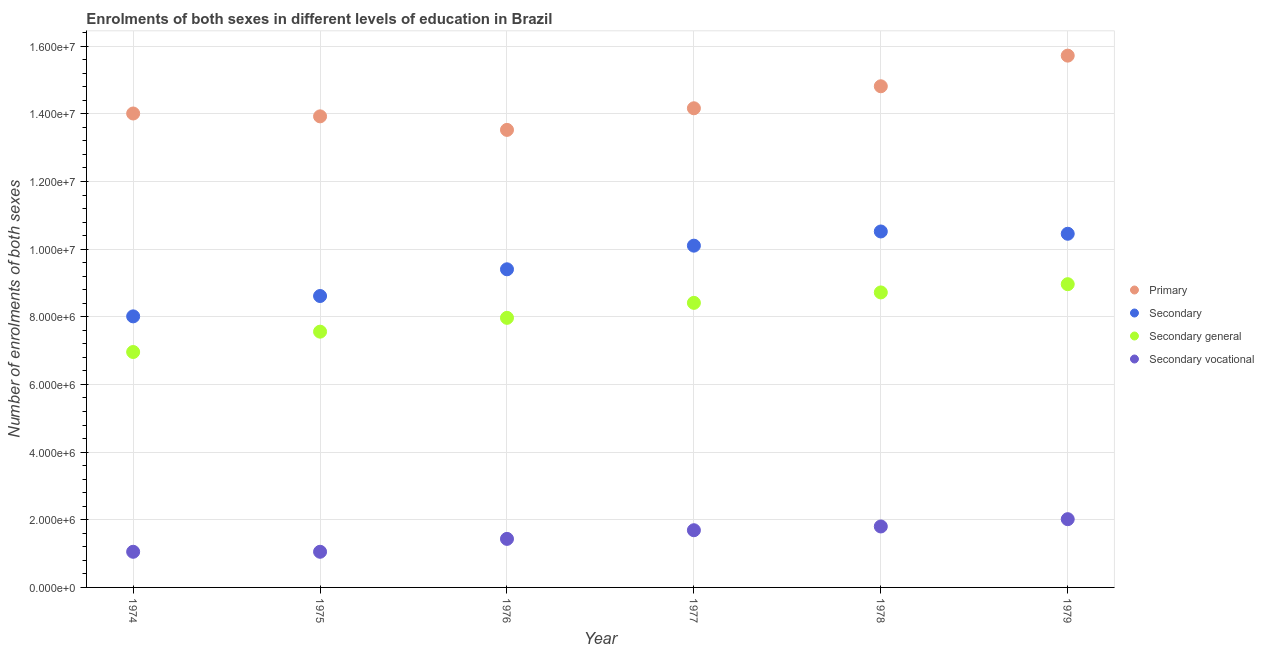How many different coloured dotlines are there?
Your answer should be very brief. 4. Is the number of dotlines equal to the number of legend labels?
Your response must be concise. Yes. What is the number of enrolments in secondary vocational education in 1975?
Make the answer very short. 1.05e+06. Across all years, what is the maximum number of enrolments in primary education?
Your answer should be very brief. 1.57e+07. Across all years, what is the minimum number of enrolments in secondary vocational education?
Your answer should be compact. 1.05e+06. In which year was the number of enrolments in secondary education maximum?
Offer a very short reply. 1978. In which year was the number of enrolments in primary education minimum?
Provide a succinct answer. 1976. What is the total number of enrolments in secondary general education in the graph?
Make the answer very short. 4.86e+07. What is the difference between the number of enrolments in primary education in 1974 and that in 1976?
Your answer should be very brief. 4.85e+05. What is the difference between the number of enrolments in secondary education in 1979 and the number of enrolments in primary education in 1978?
Your answer should be very brief. -4.36e+06. What is the average number of enrolments in primary education per year?
Provide a short and direct response. 1.44e+07. In the year 1975, what is the difference between the number of enrolments in secondary vocational education and number of enrolments in secondary general education?
Your answer should be very brief. -6.51e+06. What is the ratio of the number of enrolments in secondary vocational education in 1977 to that in 1979?
Ensure brevity in your answer.  0.84. Is the number of enrolments in secondary general education in 1976 less than that in 1977?
Offer a terse response. Yes. Is the difference between the number of enrolments in secondary vocational education in 1976 and 1979 greater than the difference between the number of enrolments in secondary general education in 1976 and 1979?
Your response must be concise. Yes. What is the difference between the highest and the second highest number of enrolments in primary education?
Keep it short and to the point. 9.06e+05. What is the difference between the highest and the lowest number of enrolments in primary education?
Provide a short and direct response. 2.20e+06. In how many years, is the number of enrolments in secondary education greater than the average number of enrolments in secondary education taken over all years?
Your answer should be very brief. 3. Is the sum of the number of enrolments in primary education in 1978 and 1979 greater than the maximum number of enrolments in secondary education across all years?
Your answer should be very brief. Yes. Is it the case that in every year, the sum of the number of enrolments in secondary general education and number of enrolments in primary education is greater than the sum of number of enrolments in secondary vocational education and number of enrolments in secondary education?
Your answer should be very brief. Yes. Is it the case that in every year, the sum of the number of enrolments in primary education and number of enrolments in secondary education is greater than the number of enrolments in secondary general education?
Your answer should be compact. Yes. How many years are there in the graph?
Make the answer very short. 6. Does the graph contain any zero values?
Keep it short and to the point. No. Where does the legend appear in the graph?
Your response must be concise. Center right. What is the title of the graph?
Provide a short and direct response. Enrolments of both sexes in different levels of education in Brazil. What is the label or title of the Y-axis?
Give a very brief answer. Number of enrolments of both sexes. What is the Number of enrolments of both sexes of Primary in 1974?
Offer a very short reply. 1.40e+07. What is the Number of enrolments of both sexes in Secondary in 1974?
Ensure brevity in your answer.  8.01e+06. What is the Number of enrolments of both sexes of Secondary general in 1974?
Your answer should be compact. 6.96e+06. What is the Number of enrolments of both sexes in Secondary vocational in 1974?
Your answer should be compact. 1.05e+06. What is the Number of enrolments of both sexes of Primary in 1975?
Ensure brevity in your answer.  1.39e+07. What is the Number of enrolments of both sexes in Secondary in 1975?
Your answer should be compact. 8.61e+06. What is the Number of enrolments of both sexes in Secondary general in 1975?
Offer a terse response. 7.56e+06. What is the Number of enrolments of both sexes in Secondary vocational in 1975?
Make the answer very short. 1.05e+06. What is the Number of enrolments of both sexes of Primary in 1976?
Keep it short and to the point. 1.35e+07. What is the Number of enrolments of both sexes in Secondary in 1976?
Make the answer very short. 9.40e+06. What is the Number of enrolments of both sexes of Secondary general in 1976?
Your answer should be very brief. 7.97e+06. What is the Number of enrolments of both sexes of Secondary vocational in 1976?
Provide a short and direct response. 1.43e+06. What is the Number of enrolments of both sexes in Primary in 1977?
Your answer should be compact. 1.42e+07. What is the Number of enrolments of both sexes of Secondary in 1977?
Your response must be concise. 1.01e+07. What is the Number of enrolments of both sexes in Secondary general in 1977?
Keep it short and to the point. 8.41e+06. What is the Number of enrolments of both sexes of Secondary vocational in 1977?
Your response must be concise. 1.69e+06. What is the Number of enrolments of both sexes of Primary in 1978?
Offer a terse response. 1.48e+07. What is the Number of enrolments of both sexes of Secondary in 1978?
Provide a succinct answer. 1.05e+07. What is the Number of enrolments of both sexes in Secondary general in 1978?
Offer a very short reply. 8.72e+06. What is the Number of enrolments of both sexes in Secondary vocational in 1978?
Your response must be concise. 1.80e+06. What is the Number of enrolments of both sexes of Primary in 1979?
Make the answer very short. 1.57e+07. What is the Number of enrolments of both sexes in Secondary in 1979?
Offer a very short reply. 1.05e+07. What is the Number of enrolments of both sexes of Secondary general in 1979?
Your answer should be compact. 8.96e+06. What is the Number of enrolments of both sexes in Secondary vocational in 1979?
Offer a very short reply. 2.02e+06. Across all years, what is the maximum Number of enrolments of both sexes in Primary?
Offer a terse response. 1.57e+07. Across all years, what is the maximum Number of enrolments of both sexes of Secondary?
Keep it short and to the point. 1.05e+07. Across all years, what is the maximum Number of enrolments of both sexes of Secondary general?
Your answer should be very brief. 8.96e+06. Across all years, what is the maximum Number of enrolments of both sexes in Secondary vocational?
Keep it short and to the point. 2.02e+06. Across all years, what is the minimum Number of enrolments of both sexes of Primary?
Give a very brief answer. 1.35e+07. Across all years, what is the minimum Number of enrolments of both sexes of Secondary?
Ensure brevity in your answer.  8.01e+06. Across all years, what is the minimum Number of enrolments of both sexes of Secondary general?
Your response must be concise. 6.96e+06. Across all years, what is the minimum Number of enrolments of both sexes in Secondary vocational?
Provide a succinct answer. 1.05e+06. What is the total Number of enrolments of both sexes in Primary in the graph?
Provide a succinct answer. 8.62e+07. What is the total Number of enrolments of both sexes of Secondary in the graph?
Keep it short and to the point. 5.71e+07. What is the total Number of enrolments of both sexes of Secondary general in the graph?
Provide a succinct answer. 4.86e+07. What is the total Number of enrolments of both sexes of Secondary vocational in the graph?
Provide a short and direct response. 9.05e+06. What is the difference between the Number of enrolments of both sexes of Primary in 1974 and that in 1975?
Keep it short and to the point. 8.45e+04. What is the difference between the Number of enrolments of both sexes in Secondary in 1974 and that in 1975?
Give a very brief answer. -6.02e+05. What is the difference between the Number of enrolments of both sexes in Secondary general in 1974 and that in 1975?
Offer a terse response. -6.01e+05. What is the difference between the Number of enrolments of both sexes of Secondary vocational in 1974 and that in 1975?
Offer a very short reply. -294. What is the difference between the Number of enrolments of both sexes of Primary in 1974 and that in 1976?
Offer a terse response. 4.85e+05. What is the difference between the Number of enrolments of both sexes of Secondary in 1974 and that in 1976?
Provide a succinct answer. -1.39e+06. What is the difference between the Number of enrolments of both sexes in Secondary general in 1974 and that in 1976?
Give a very brief answer. -1.01e+06. What is the difference between the Number of enrolments of both sexes in Secondary vocational in 1974 and that in 1976?
Provide a short and direct response. -3.81e+05. What is the difference between the Number of enrolments of both sexes of Primary in 1974 and that in 1977?
Provide a succinct answer. -1.54e+05. What is the difference between the Number of enrolments of both sexes of Secondary in 1974 and that in 1977?
Provide a succinct answer. -2.09e+06. What is the difference between the Number of enrolments of both sexes of Secondary general in 1974 and that in 1977?
Offer a very short reply. -1.45e+06. What is the difference between the Number of enrolments of both sexes in Secondary vocational in 1974 and that in 1977?
Give a very brief answer. -6.37e+05. What is the difference between the Number of enrolments of both sexes of Primary in 1974 and that in 1978?
Ensure brevity in your answer.  -8.05e+05. What is the difference between the Number of enrolments of both sexes of Secondary in 1974 and that in 1978?
Your answer should be very brief. -2.51e+06. What is the difference between the Number of enrolments of both sexes of Secondary general in 1974 and that in 1978?
Ensure brevity in your answer.  -1.76e+06. What is the difference between the Number of enrolments of both sexes in Secondary vocational in 1974 and that in 1978?
Your answer should be very brief. -7.48e+05. What is the difference between the Number of enrolments of both sexes in Primary in 1974 and that in 1979?
Ensure brevity in your answer.  -1.71e+06. What is the difference between the Number of enrolments of both sexes of Secondary in 1974 and that in 1979?
Keep it short and to the point. -2.44e+06. What is the difference between the Number of enrolments of both sexes in Secondary general in 1974 and that in 1979?
Offer a very short reply. -2.00e+06. What is the difference between the Number of enrolments of both sexes of Secondary vocational in 1974 and that in 1979?
Keep it short and to the point. -9.64e+05. What is the difference between the Number of enrolments of both sexes of Primary in 1975 and that in 1976?
Your answer should be very brief. 4.00e+05. What is the difference between the Number of enrolments of both sexes of Secondary in 1975 and that in 1976?
Keep it short and to the point. -7.90e+05. What is the difference between the Number of enrolments of both sexes of Secondary general in 1975 and that in 1976?
Your response must be concise. -4.09e+05. What is the difference between the Number of enrolments of both sexes in Secondary vocational in 1975 and that in 1976?
Make the answer very short. -3.81e+05. What is the difference between the Number of enrolments of both sexes in Primary in 1975 and that in 1977?
Your answer should be very brief. -2.39e+05. What is the difference between the Number of enrolments of both sexes of Secondary in 1975 and that in 1977?
Your response must be concise. -1.49e+06. What is the difference between the Number of enrolments of both sexes in Secondary general in 1975 and that in 1977?
Ensure brevity in your answer.  -8.51e+05. What is the difference between the Number of enrolments of both sexes of Secondary vocational in 1975 and that in 1977?
Your response must be concise. -6.37e+05. What is the difference between the Number of enrolments of both sexes of Primary in 1975 and that in 1978?
Your answer should be very brief. -8.89e+05. What is the difference between the Number of enrolments of both sexes of Secondary in 1975 and that in 1978?
Ensure brevity in your answer.  -1.91e+06. What is the difference between the Number of enrolments of both sexes of Secondary general in 1975 and that in 1978?
Your answer should be compact. -1.16e+06. What is the difference between the Number of enrolments of both sexes of Secondary vocational in 1975 and that in 1978?
Give a very brief answer. -7.48e+05. What is the difference between the Number of enrolments of both sexes in Primary in 1975 and that in 1979?
Make the answer very short. -1.79e+06. What is the difference between the Number of enrolments of both sexes of Secondary in 1975 and that in 1979?
Your answer should be compact. -1.84e+06. What is the difference between the Number of enrolments of both sexes in Secondary general in 1975 and that in 1979?
Your response must be concise. -1.40e+06. What is the difference between the Number of enrolments of both sexes in Secondary vocational in 1975 and that in 1979?
Your answer should be very brief. -9.64e+05. What is the difference between the Number of enrolments of both sexes in Primary in 1976 and that in 1977?
Your answer should be very brief. -6.39e+05. What is the difference between the Number of enrolments of both sexes in Secondary in 1976 and that in 1977?
Offer a terse response. -6.99e+05. What is the difference between the Number of enrolments of both sexes in Secondary general in 1976 and that in 1977?
Your response must be concise. -4.43e+05. What is the difference between the Number of enrolments of both sexes of Secondary vocational in 1976 and that in 1977?
Offer a terse response. -2.56e+05. What is the difference between the Number of enrolments of both sexes in Primary in 1976 and that in 1978?
Offer a very short reply. -1.29e+06. What is the difference between the Number of enrolments of both sexes of Secondary in 1976 and that in 1978?
Keep it short and to the point. -1.12e+06. What is the difference between the Number of enrolments of both sexes of Secondary general in 1976 and that in 1978?
Provide a succinct answer. -7.51e+05. What is the difference between the Number of enrolments of both sexes in Secondary vocational in 1976 and that in 1978?
Offer a terse response. -3.67e+05. What is the difference between the Number of enrolments of both sexes of Primary in 1976 and that in 1979?
Keep it short and to the point. -2.20e+06. What is the difference between the Number of enrolments of both sexes in Secondary in 1976 and that in 1979?
Provide a succinct answer. -1.05e+06. What is the difference between the Number of enrolments of both sexes in Secondary general in 1976 and that in 1979?
Provide a succinct answer. -9.95e+05. What is the difference between the Number of enrolments of both sexes of Secondary vocational in 1976 and that in 1979?
Keep it short and to the point. -5.82e+05. What is the difference between the Number of enrolments of both sexes of Primary in 1977 and that in 1978?
Offer a terse response. -6.50e+05. What is the difference between the Number of enrolments of both sexes of Secondary in 1977 and that in 1978?
Provide a succinct answer. -4.19e+05. What is the difference between the Number of enrolments of both sexes of Secondary general in 1977 and that in 1978?
Make the answer very short. -3.08e+05. What is the difference between the Number of enrolments of both sexes of Secondary vocational in 1977 and that in 1978?
Your answer should be compact. -1.11e+05. What is the difference between the Number of enrolments of both sexes of Primary in 1977 and that in 1979?
Your answer should be very brief. -1.56e+06. What is the difference between the Number of enrolments of both sexes in Secondary in 1977 and that in 1979?
Provide a short and direct response. -3.52e+05. What is the difference between the Number of enrolments of both sexes in Secondary general in 1977 and that in 1979?
Keep it short and to the point. -5.52e+05. What is the difference between the Number of enrolments of both sexes of Secondary vocational in 1977 and that in 1979?
Your response must be concise. -3.27e+05. What is the difference between the Number of enrolments of both sexes of Primary in 1978 and that in 1979?
Provide a succinct answer. -9.06e+05. What is the difference between the Number of enrolments of both sexes of Secondary in 1978 and that in 1979?
Make the answer very short. 6.76e+04. What is the difference between the Number of enrolments of both sexes in Secondary general in 1978 and that in 1979?
Your answer should be compact. -2.44e+05. What is the difference between the Number of enrolments of both sexes of Secondary vocational in 1978 and that in 1979?
Your answer should be compact. -2.16e+05. What is the difference between the Number of enrolments of both sexes in Primary in 1974 and the Number of enrolments of both sexes in Secondary in 1975?
Ensure brevity in your answer.  5.40e+06. What is the difference between the Number of enrolments of both sexes in Primary in 1974 and the Number of enrolments of both sexes in Secondary general in 1975?
Provide a succinct answer. 6.45e+06. What is the difference between the Number of enrolments of both sexes in Primary in 1974 and the Number of enrolments of both sexes in Secondary vocational in 1975?
Your answer should be compact. 1.30e+07. What is the difference between the Number of enrolments of both sexes of Secondary in 1974 and the Number of enrolments of both sexes of Secondary general in 1975?
Keep it short and to the point. 4.52e+05. What is the difference between the Number of enrolments of both sexes in Secondary in 1974 and the Number of enrolments of both sexes in Secondary vocational in 1975?
Your answer should be compact. 6.96e+06. What is the difference between the Number of enrolments of both sexes of Secondary general in 1974 and the Number of enrolments of both sexes of Secondary vocational in 1975?
Give a very brief answer. 5.91e+06. What is the difference between the Number of enrolments of both sexes of Primary in 1974 and the Number of enrolments of both sexes of Secondary in 1976?
Provide a succinct answer. 4.61e+06. What is the difference between the Number of enrolments of both sexes in Primary in 1974 and the Number of enrolments of both sexes in Secondary general in 1976?
Your response must be concise. 6.04e+06. What is the difference between the Number of enrolments of both sexes in Primary in 1974 and the Number of enrolments of both sexes in Secondary vocational in 1976?
Provide a succinct answer. 1.26e+07. What is the difference between the Number of enrolments of both sexes of Secondary in 1974 and the Number of enrolments of both sexes of Secondary general in 1976?
Ensure brevity in your answer.  4.35e+04. What is the difference between the Number of enrolments of both sexes in Secondary in 1974 and the Number of enrolments of both sexes in Secondary vocational in 1976?
Your response must be concise. 6.58e+06. What is the difference between the Number of enrolments of both sexes in Secondary general in 1974 and the Number of enrolments of both sexes in Secondary vocational in 1976?
Ensure brevity in your answer.  5.52e+06. What is the difference between the Number of enrolments of both sexes in Primary in 1974 and the Number of enrolments of both sexes in Secondary in 1977?
Make the answer very short. 3.91e+06. What is the difference between the Number of enrolments of both sexes in Primary in 1974 and the Number of enrolments of both sexes in Secondary general in 1977?
Make the answer very short. 5.60e+06. What is the difference between the Number of enrolments of both sexes of Primary in 1974 and the Number of enrolments of both sexes of Secondary vocational in 1977?
Your answer should be compact. 1.23e+07. What is the difference between the Number of enrolments of both sexes in Secondary in 1974 and the Number of enrolments of both sexes in Secondary general in 1977?
Offer a very short reply. -3.99e+05. What is the difference between the Number of enrolments of both sexes of Secondary in 1974 and the Number of enrolments of both sexes of Secondary vocational in 1977?
Your response must be concise. 6.32e+06. What is the difference between the Number of enrolments of both sexes of Secondary general in 1974 and the Number of enrolments of both sexes of Secondary vocational in 1977?
Offer a very short reply. 5.27e+06. What is the difference between the Number of enrolments of both sexes of Primary in 1974 and the Number of enrolments of both sexes of Secondary in 1978?
Offer a terse response. 3.49e+06. What is the difference between the Number of enrolments of both sexes of Primary in 1974 and the Number of enrolments of both sexes of Secondary general in 1978?
Offer a terse response. 5.29e+06. What is the difference between the Number of enrolments of both sexes in Primary in 1974 and the Number of enrolments of both sexes in Secondary vocational in 1978?
Provide a short and direct response. 1.22e+07. What is the difference between the Number of enrolments of both sexes in Secondary in 1974 and the Number of enrolments of both sexes in Secondary general in 1978?
Make the answer very short. -7.08e+05. What is the difference between the Number of enrolments of both sexes of Secondary in 1974 and the Number of enrolments of both sexes of Secondary vocational in 1978?
Provide a short and direct response. 6.21e+06. What is the difference between the Number of enrolments of both sexes of Secondary general in 1974 and the Number of enrolments of both sexes of Secondary vocational in 1978?
Provide a short and direct response. 5.16e+06. What is the difference between the Number of enrolments of both sexes of Primary in 1974 and the Number of enrolments of both sexes of Secondary in 1979?
Your response must be concise. 3.56e+06. What is the difference between the Number of enrolments of both sexes in Primary in 1974 and the Number of enrolments of both sexes in Secondary general in 1979?
Make the answer very short. 5.05e+06. What is the difference between the Number of enrolments of both sexes in Primary in 1974 and the Number of enrolments of both sexes in Secondary vocational in 1979?
Offer a very short reply. 1.20e+07. What is the difference between the Number of enrolments of both sexes in Secondary in 1974 and the Number of enrolments of both sexes in Secondary general in 1979?
Keep it short and to the point. -9.51e+05. What is the difference between the Number of enrolments of both sexes of Secondary in 1974 and the Number of enrolments of both sexes of Secondary vocational in 1979?
Offer a very short reply. 6.00e+06. What is the difference between the Number of enrolments of both sexes in Secondary general in 1974 and the Number of enrolments of both sexes in Secondary vocational in 1979?
Provide a short and direct response. 4.94e+06. What is the difference between the Number of enrolments of both sexes in Primary in 1975 and the Number of enrolments of both sexes in Secondary in 1976?
Keep it short and to the point. 4.52e+06. What is the difference between the Number of enrolments of both sexes of Primary in 1975 and the Number of enrolments of both sexes of Secondary general in 1976?
Ensure brevity in your answer.  5.96e+06. What is the difference between the Number of enrolments of both sexes in Primary in 1975 and the Number of enrolments of both sexes in Secondary vocational in 1976?
Keep it short and to the point. 1.25e+07. What is the difference between the Number of enrolments of both sexes in Secondary in 1975 and the Number of enrolments of both sexes in Secondary general in 1976?
Ensure brevity in your answer.  6.45e+05. What is the difference between the Number of enrolments of both sexes in Secondary in 1975 and the Number of enrolments of both sexes in Secondary vocational in 1976?
Keep it short and to the point. 7.18e+06. What is the difference between the Number of enrolments of both sexes in Secondary general in 1975 and the Number of enrolments of both sexes in Secondary vocational in 1976?
Your answer should be compact. 6.13e+06. What is the difference between the Number of enrolments of both sexes of Primary in 1975 and the Number of enrolments of both sexes of Secondary in 1977?
Keep it short and to the point. 3.82e+06. What is the difference between the Number of enrolments of both sexes of Primary in 1975 and the Number of enrolments of both sexes of Secondary general in 1977?
Provide a succinct answer. 5.51e+06. What is the difference between the Number of enrolments of both sexes of Primary in 1975 and the Number of enrolments of both sexes of Secondary vocational in 1977?
Ensure brevity in your answer.  1.22e+07. What is the difference between the Number of enrolments of both sexes of Secondary in 1975 and the Number of enrolments of both sexes of Secondary general in 1977?
Your answer should be very brief. 2.02e+05. What is the difference between the Number of enrolments of both sexes in Secondary in 1975 and the Number of enrolments of both sexes in Secondary vocational in 1977?
Your response must be concise. 6.92e+06. What is the difference between the Number of enrolments of both sexes of Secondary general in 1975 and the Number of enrolments of both sexes of Secondary vocational in 1977?
Offer a terse response. 5.87e+06. What is the difference between the Number of enrolments of both sexes of Primary in 1975 and the Number of enrolments of both sexes of Secondary in 1978?
Keep it short and to the point. 3.40e+06. What is the difference between the Number of enrolments of both sexes in Primary in 1975 and the Number of enrolments of both sexes in Secondary general in 1978?
Make the answer very short. 5.20e+06. What is the difference between the Number of enrolments of both sexes of Primary in 1975 and the Number of enrolments of both sexes of Secondary vocational in 1978?
Provide a short and direct response. 1.21e+07. What is the difference between the Number of enrolments of both sexes of Secondary in 1975 and the Number of enrolments of both sexes of Secondary general in 1978?
Your response must be concise. -1.06e+05. What is the difference between the Number of enrolments of both sexes of Secondary in 1975 and the Number of enrolments of both sexes of Secondary vocational in 1978?
Your response must be concise. 6.81e+06. What is the difference between the Number of enrolments of both sexes in Secondary general in 1975 and the Number of enrolments of both sexes in Secondary vocational in 1978?
Your answer should be compact. 5.76e+06. What is the difference between the Number of enrolments of both sexes of Primary in 1975 and the Number of enrolments of both sexes of Secondary in 1979?
Make the answer very short. 3.47e+06. What is the difference between the Number of enrolments of both sexes in Primary in 1975 and the Number of enrolments of both sexes in Secondary general in 1979?
Make the answer very short. 4.96e+06. What is the difference between the Number of enrolments of both sexes in Primary in 1975 and the Number of enrolments of both sexes in Secondary vocational in 1979?
Offer a very short reply. 1.19e+07. What is the difference between the Number of enrolments of both sexes of Secondary in 1975 and the Number of enrolments of both sexes of Secondary general in 1979?
Provide a succinct answer. -3.50e+05. What is the difference between the Number of enrolments of both sexes of Secondary in 1975 and the Number of enrolments of both sexes of Secondary vocational in 1979?
Keep it short and to the point. 6.60e+06. What is the difference between the Number of enrolments of both sexes in Secondary general in 1975 and the Number of enrolments of both sexes in Secondary vocational in 1979?
Provide a succinct answer. 5.54e+06. What is the difference between the Number of enrolments of both sexes of Primary in 1976 and the Number of enrolments of both sexes of Secondary in 1977?
Ensure brevity in your answer.  3.42e+06. What is the difference between the Number of enrolments of both sexes of Primary in 1976 and the Number of enrolments of both sexes of Secondary general in 1977?
Make the answer very short. 5.11e+06. What is the difference between the Number of enrolments of both sexes of Primary in 1976 and the Number of enrolments of both sexes of Secondary vocational in 1977?
Offer a very short reply. 1.18e+07. What is the difference between the Number of enrolments of both sexes in Secondary in 1976 and the Number of enrolments of both sexes in Secondary general in 1977?
Offer a terse response. 9.92e+05. What is the difference between the Number of enrolments of both sexes in Secondary in 1976 and the Number of enrolments of both sexes in Secondary vocational in 1977?
Offer a very short reply. 7.71e+06. What is the difference between the Number of enrolments of both sexes in Secondary general in 1976 and the Number of enrolments of both sexes in Secondary vocational in 1977?
Offer a terse response. 6.28e+06. What is the difference between the Number of enrolments of both sexes of Primary in 1976 and the Number of enrolments of both sexes of Secondary in 1978?
Provide a short and direct response. 3.00e+06. What is the difference between the Number of enrolments of both sexes of Primary in 1976 and the Number of enrolments of both sexes of Secondary general in 1978?
Your answer should be compact. 4.80e+06. What is the difference between the Number of enrolments of both sexes in Primary in 1976 and the Number of enrolments of both sexes in Secondary vocational in 1978?
Your answer should be very brief. 1.17e+07. What is the difference between the Number of enrolments of both sexes of Secondary in 1976 and the Number of enrolments of both sexes of Secondary general in 1978?
Provide a short and direct response. 6.84e+05. What is the difference between the Number of enrolments of both sexes in Secondary in 1976 and the Number of enrolments of both sexes in Secondary vocational in 1978?
Your answer should be very brief. 7.60e+06. What is the difference between the Number of enrolments of both sexes in Secondary general in 1976 and the Number of enrolments of both sexes in Secondary vocational in 1978?
Ensure brevity in your answer.  6.17e+06. What is the difference between the Number of enrolments of both sexes in Primary in 1976 and the Number of enrolments of both sexes in Secondary in 1979?
Ensure brevity in your answer.  3.07e+06. What is the difference between the Number of enrolments of both sexes of Primary in 1976 and the Number of enrolments of both sexes of Secondary general in 1979?
Provide a short and direct response. 4.56e+06. What is the difference between the Number of enrolments of both sexes of Primary in 1976 and the Number of enrolments of both sexes of Secondary vocational in 1979?
Provide a short and direct response. 1.15e+07. What is the difference between the Number of enrolments of both sexes in Secondary in 1976 and the Number of enrolments of both sexes in Secondary general in 1979?
Your answer should be very brief. 4.40e+05. What is the difference between the Number of enrolments of both sexes of Secondary in 1976 and the Number of enrolments of both sexes of Secondary vocational in 1979?
Your answer should be compact. 7.39e+06. What is the difference between the Number of enrolments of both sexes of Secondary general in 1976 and the Number of enrolments of both sexes of Secondary vocational in 1979?
Provide a short and direct response. 5.95e+06. What is the difference between the Number of enrolments of both sexes in Primary in 1977 and the Number of enrolments of both sexes in Secondary in 1978?
Your response must be concise. 3.64e+06. What is the difference between the Number of enrolments of both sexes in Primary in 1977 and the Number of enrolments of both sexes in Secondary general in 1978?
Your answer should be very brief. 5.44e+06. What is the difference between the Number of enrolments of both sexes of Primary in 1977 and the Number of enrolments of both sexes of Secondary vocational in 1978?
Provide a succinct answer. 1.24e+07. What is the difference between the Number of enrolments of both sexes of Secondary in 1977 and the Number of enrolments of both sexes of Secondary general in 1978?
Provide a short and direct response. 1.38e+06. What is the difference between the Number of enrolments of both sexes of Secondary in 1977 and the Number of enrolments of both sexes of Secondary vocational in 1978?
Offer a very short reply. 8.30e+06. What is the difference between the Number of enrolments of both sexes in Secondary general in 1977 and the Number of enrolments of both sexes in Secondary vocational in 1978?
Give a very brief answer. 6.61e+06. What is the difference between the Number of enrolments of both sexes in Primary in 1977 and the Number of enrolments of both sexes in Secondary in 1979?
Make the answer very short. 3.71e+06. What is the difference between the Number of enrolments of both sexes in Primary in 1977 and the Number of enrolments of both sexes in Secondary general in 1979?
Your answer should be compact. 5.20e+06. What is the difference between the Number of enrolments of both sexes in Primary in 1977 and the Number of enrolments of both sexes in Secondary vocational in 1979?
Your answer should be very brief. 1.21e+07. What is the difference between the Number of enrolments of both sexes in Secondary in 1977 and the Number of enrolments of both sexes in Secondary general in 1979?
Provide a succinct answer. 1.14e+06. What is the difference between the Number of enrolments of both sexes in Secondary in 1977 and the Number of enrolments of both sexes in Secondary vocational in 1979?
Your answer should be very brief. 8.09e+06. What is the difference between the Number of enrolments of both sexes of Secondary general in 1977 and the Number of enrolments of both sexes of Secondary vocational in 1979?
Ensure brevity in your answer.  6.39e+06. What is the difference between the Number of enrolments of both sexes of Primary in 1978 and the Number of enrolments of both sexes of Secondary in 1979?
Give a very brief answer. 4.36e+06. What is the difference between the Number of enrolments of both sexes of Primary in 1978 and the Number of enrolments of both sexes of Secondary general in 1979?
Provide a succinct answer. 5.85e+06. What is the difference between the Number of enrolments of both sexes of Primary in 1978 and the Number of enrolments of both sexes of Secondary vocational in 1979?
Ensure brevity in your answer.  1.28e+07. What is the difference between the Number of enrolments of both sexes in Secondary in 1978 and the Number of enrolments of both sexes in Secondary general in 1979?
Your answer should be compact. 1.56e+06. What is the difference between the Number of enrolments of both sexes in Secondary in 1978 and the Number of enrolments of both sexes in Secondary vocational in 1979?
Your response must be concise. 8.50e+06. What is the difference between the Number of enrolments of both sexes in Secondary general in 1978 and the Number of enrolments of both sexes in Secondary vocational in 1979?
Provide a succinct answer. 6.70e+06. What is the average Number of enrolments of both sexes in Primary per year?
Provide a succinct answer. 1.44e+07. What is the average Number of enrolments of both sexes of Secondary per year?
Provide a succinct answer. 9.52e+06. What is the average Number of enrolments of both sexes of Secondary general per year?
Your answer should be very brief. 8.10e+06. What is the average Number of enrolments of both sexes of Secondary vocational per year?
Give a very brief answer. 1.51e+06. In the year 1974, what is the difference between the Number of enrolments of both sexes in Primary and Number of enrolments of both sexes in Secondary?
Offer a very short reply. 6.00e+06. In the year 1974, what is the difference between the Number of enrolments of both sexes of Primary and Number of enrolments of both sexes of Secondary general?
Keep it short and to the point. 7.05e+06. In the year 1974, what is the difference between the Number of enrolments of both sexes of Primary and Number of enrolments of both sexes of Secondary vocational?
Ensure brevity in your answer.  1.30e+07. In the year 1974, what is the difference between the Number of enrolments of both sexes in Secondary and Number of enrolments of both sexes in Secondary general?
Offer a terse response. 1.05e+06. In the year 1974, what is the difference between the Number of enrolments of both sexes of Secondary and Number of enrolments of both sexes of Secondary vocational?
Keep it short and to the point. 6.96e+06. In the year 1974, what is the difference between the Number of enrolments of both sexes in Secondary general and Number of enrolments of both sexes in Secondary vocational?
Your answer should be very brief. 5.91e+06. In the year 1975, what is the difference between the Number of enrolments of both sexes in Primary and Number of enrolments of both sexes in Secondary?
Offer a terse response. 5.31e+06. In the year 1975, what is the difference between the Number of enrolments of both sexes in Primary and Number of enrolments of both sexes in Secondary general?
Your answer should be very brief. 6.36e+06. In the year 1975, what is the difference between the Number of enrolments of both sexes in Primary and Number of enrolments of both sexes in Secondary vocational?
Give a very brief answer. 1.29e+07. In the year 1975, what is the difference between the Number of enrolments of both sexes in Secondary and Number of enrolments of both sexes in Secondary general?
Keep it short and to the point. 1.05e+06. In the year 1975, what is the difference between the Number of enrolments of both sexes in Secondary and Number of enrolments of both sexes in Secondary vocational?
Make the answer very short. 7.56e+06. In the year 1975, what is the difference between the Number of enrolments of both sexes of Secondary general and Number of enrolments of both sexes of Secondary vocational?
Your answer should be compact. 6.51e+06. In the year 1976, what is the difference between the Number of enrolments of both sexes in Primary and Number of enrolments of both sexes in Secondary?
Keep it short and to the point. 4.12e+06. In the year 1976, what is the difference between the Number of enrolments of both sexes in Primary and Number of enrolments of both sexes in Secondary general?
Your response must be concise. 5.56e+06. In the year 1976, what is the difference between the Number of enrolments of both sexes of Primary and Number of enrolments of both sexes of Secondary vocational?
Provide a short and direct response. 1.21e+07. In the year 1976, what is the difference between the Number of enrolments of both sexes of Secondary and Number of enrolments of both sexes of Secondary general?
Provide a short and direct response. 1.43e+06. In the year 1976, what is the difference between the Number of enrolments of both sexes of Secondary and Number of enrolments of both sexes of Secondary vocational?
Provide a short and direct response. 7.97e+06. In the year 1976, what is the difference between the Number of enrolments of both sexes of Secondary general and Number of enrolments of both sexes of Secondary vocational?
Provide a succinct answer. 6.53e+06. In the year 1977, what is the difference between the Number of enrolments of both sexes in Primary and Number of enrolments of both sexes in Secondary?
Offer a terse response. 4.06e+06. In the year 1977, what is the difference between the Number of enrolments of both sexes of Primary and Number of enrolments of both sexes of Secondary general?
Your answer should be very brief. 5.75e+06. In the year 1977, what is the difference between the Number of enrolments of both sexes in Primary and Number of enrolments of both sexes in Secondary vocational?
Keep it short and to the point. 1.25e+07. In the year 1977, what is the difference between the Number of enrolments of both sexes of Secondary and Number of enrolments of both sexes of Secondary general?
Provide a short and direct response. 1.69e+06. In the year 1977, what is the difference between the Number of enrolments of both sexes in Secondary and Number of enrolments of both sexes in Secondary vocational?
Offer a terse response. 8.41e+06. In the year 1977, what is the difference between the Number of enrolments of both sexes of Secondary general and Number of enrolments of both sexes of Secondary vocational?
Your answer should be compact. 6.72e+06. In the year 1978, what is the difference between the Number of enrolments of both sexes of Primary and Number of enrolments of both sexes of Secondary?
Ensure brevity in your answer.  4.29e+06. In the year 1978, what is the difference between the Number of enrolments of both sexes of Primary and Number of enrolments of both sexes of Secondary general?
Your answer should be very brief. 6.09e+06. In the year 1978, what is the difference between the Number of enrolments of both sexes of Primary and Number of enrolments of both sexes of Secondary vocational?
Offer a very short reply. 1.30e+07. In the year 1978, what is the difference between the Number of enrolments of both sexes in Secondary and Number of enrolments of both sexes in Secondary general?
Your answer should be compact. 1.80e+06. In the year 1978, what is the difference between the Number of enrolments of both sexes in Secondary and Number of enrolments of both sexes in Secondary vocational?
Provide a succinct answer. 8.72e+06. In the year 1978, what is the difference between the Number of enrolments of both sexes in Secondary general and Number of enrolments of both sexes in Secondary vocational?
Offer a very short reply. 6.92e+06. In the year 1979, what is the difference between the Number of enrolments of both sexes of Primary and Number of enrolments of both sexes of Secondary?
Keep it short and to the point. 5.27e+06. In the year 1979, what is the difference between the Number of enrolments of both sexes of Primary and Number of enrolments of both sexes of Secondary general?
Offer a very short reply. 6.76e+06. In the year 1979, what is the difference between the Number of enrolments of both sexes in Primary and Number of enrolments of both sexes in Secondary vocational?
Your answer should be very brief. 1.37e+07. In the year 1979, what is the difference between the Number of enrolments of both sexes of Secondary and Number of enrolments of both sexes of Secondary general?
Give a very brief answer. 1.49e+06. In the year 1979, what is the difference between the Number of enrolments of both sexes in Secondary and Number of enrolments of both sexes in Secondary vocational?
Make the answer very short. 8.44e+06. In the year 1979, what is the difference between the Number of enrolments of both sexes in Secondary general and Number of enrolments of both sexes in Secondary vocational?
Your response must be concise. 6.95e+06. What is the ratio of the Number of enrolments of both sexes in Primary in 1974 to that in 1975?
Your answer should be compact. 1.01. What is the ratio of the Number of enrolments of both sexes of Secondary in 1974 to that in 1975?
Make the answer very short. 0.93. What is the ratio of the Number of enrolments of both sexes of Secondary general in 1974 to that in 1975?
Your answer should be compact. 0.92. What is the ratio of the Number of enrolments of both sexes in Primary in 1974 to that in 1976?
Ensure brevity in your answer.  1.04. What is the ratio of the Number of enrolments of both sexes of Secondary in 1974 to that in 1976?
Offer a very short reply. 0.85. What is the ratio of the Number of enrolments of both sexes of Secondary general in 1974 to that in 1976?
Make the answer very short. 0.87. What is the ratio of the Number of enrolments of both sexes of Secondary vocational in 1974 to that in 1976?
Make the answer very short. 0.73. What is the ratio of the Number of enrolments of both sexes of Primary in 1974 to that in 1977?
Make the answer very short. 0.99. What is the ratio of the Number of enrolments of both sexes in Secondary in 1974 to that in 1977?
Provide a succinct answer. 0.79. What is the ratio of the Number of enrolments of both sexes of Secondary general in 1974 to that in 1977?
Give a very brief answer. 0.83. What is the ratio of the Number of enrolments of both sexes of Secondary vocational in 1974 to that in 1977?
Your answer should be compact. 0.62. What is the ratio of the Number of enrolments of both sexes of Primary in 1974 to that in 1978?
Offer a terse response. 0.95. What is the ratio of the Number of enrolments of both sexes of Secondary in 1974 to that in 1978?
Your response must be concise. 0.76. What is the ratio of the Number of enrolments of both sexes in Secondary general in 1974 to that in 1978?
Offer a very short reply. 0.8. What is the ratio of the Number of enrolments of both sexes in Secondary vocational in 1974 to that in 1978?
Give a very brief answer. 0.58. What is the ratio of the Number of enrolments of both sexes of Primary in 1974 to that in 1979?
Give a very brief answer. 0.89. What is the ratio of the Number of enrolments of both sexes in Secondary in 1974 to that in 1979?
Your response must be concise. 0.77. What is the ratio of the Number of enrolments of both sexes of Secondary general in 1974 to that in 1979?
Offer a terse response. 0.78. What is the ratio of the Number of enrolments of both sexes in Secondary vocational in 1974 to that in 1979?
Make the answer very short. 0.52. What is the ratio of the Number of enrolments of both sexes of Primary in 1975 to that in 1976?
Provide a succinct answer. 1.03. What is the ratio of the Number of enrolments of both sexes of Secondary in 1975 to that in 1976?
Provide a succinct answer. 0.92. What is the ratio of the Number of enrolments of both sexes in Secondary general in 1975 to that in 1976?
Give a very brief answer. 0.95. What is the ratio of the Number of enrolments of both sexes in Secondary vocational in 1975 to that in 1976?
Offer a very short reply. 0.73. What is the ratio of the Number of enrolments of both sexes of Primary in 1975 to that in 1977?
Your answer should be compact. 0.98. What is the ratio of the Number of enrolments of both sexes of Secondary in 1975 to that in 1977?
Your answer should be compact. 0.85. What is the ratio of the Number of enrolments of both sexes of Secondary general in 1975 to that in 1977?
Provide a succinct answer. 0.9. What is the ratio of the Number of enrolments of both sexes of Secondary vocational in 1975 to that in 1977?
Ensure brevity in your answer.  0.62. What is the ratio of the Number of enrolments of both sexes in Primary in 1975 to that in 1978?
Make the answer very short. 0.94. What is the ratio of the Number of enrolments of both sexes in Secondary in 1975 to that in 1978?
Make the answer very short. 0.82. What is the ratio of the Number of enrolments of both sexes in Secondary general in 1975 to that in 1978?
Give a very brief answer. 0.87. What is the ratio of the Number of enrolments of both sexes of Secondary vocational in 1975 to that in 1978?
Your response must be concise. 0.58. What is the ratio of the Number of enrolments of both sexes in Primary in 1975 to that in 1979?
Provide a short and direct response. 0.89. What is the ratio of the Number of enrolments of both sexes in Secondary in 1975 to that in 1979?
Provide a short and direct response. 0.82. What is the ratio of the Number of enrolments of both sexes in Secondary general in 1975 to that in 1979?
Provide a succinct answer. 0.84. What is the ratio of the Number of enrolments of both sexes in Secondary vocational in 1975 to that in 1979?
Your response must be concise. 0.52. What is the ratio of the Number of enrolments of both sexes in Primary in 1976 to that in 1977?
Offer a very short reply. 0.95. What is the ratio of the Number of enrolments of both sexes of Secondary in 1976 to that in 1977?
Provide a succinct answer. 0.93. What is the ratio of the Number of enrolments of both sexes of Secondary general in 1976 to that in 1977?
Provide a succinct answer. 0.95. What is the ratio of the Number of enrolments of both sexes in Secondary vocational in 1976 to that in 1977?
Your answer should be very brief. 0.85. What is the ratio of the Number of enrolments of both sexes of Secondary in 1976 to that in 1978?
Your answer should be compact. 0.89. What is the ratio of the Number of enrolments of both sexes in Secondary general in 1976 to that in 1978?
Provide a short and direct response. 0.91. What is the ratio of the Number of enrolments of both sexes of Secondary vocational in 1976 to that in 1978?
Offer a terse response. 0.8. What is the ratio of the Number of enrolments of both sexes of Primary in 1976 to that in 1979?
Offer a very short reply. 0.86. What is the ratio of the Number of enrolments of both sexes in Secondary in 1976 to that in 1979?
Provide a succinct answer. 0.9. What is the ratio of the Number of enrolments of both sexes of Secondary general in 1976 to that in 1979?
Ensure brevity in your answer.  0.89. What is the ratio of the Number of enrolments of both sexes of Secondary vocational in 1976 to that in 1979?
Provide a succinct answer. 0.71. What is the ratio of the Number of enrolments of both sexes of Primary in 1977 to that in 1978?
Provide a succinct answer. 0.96. What is the ratio of the Number of enrolments of both sexes of Secondary in 1977 to that in 1978?
Provide a succinct answer. 0.96. What is the ratio of the Number of enrolments of both sexes in Secondary general in 1977 to that in 1978?
Your answer should be very brief. 0.96. What is the ratio of the Number of enrolments of both sexes of Secondary vocational in 1977 to that in 1978?
Keep it short and to the point. 0.94. What is the ratio of the Number of enrolments of both sexes of Primary in 1977 to that in 1979?
Give a very brief answer. 0.9. What is the ratio of the Number of enrolments of both sexes in Secondary in 1977 to that in 1979?
Keep it short and to the point. 0.97. What is the ratio of the Number of enrolments of both sexes of Secondary general in 1977 to that in 1979?
Provide a short and direct response. 0.94. What is the ratio of the Number of enrolments of both sexes of Secondary vocational in 1977 to that in 1979?
Your response must be concise. 0.84. What is the ratio of the Number of enrolments of both sexes of Primary in 1978 to that in 1979?
Offer a terse response. 0.94. What is the ratio of the Number of enrolments of both sexes in Secondary general in 1978 to that in 1979?
Offer a terse response. 0.97. What is the ratio of the Number of enrolments of both sexes of Secondary vocational in 1978 to that in 1979?
Offer a very short reply. 0.89. What is the difference between the highest and the second highest Number of enrolments of both sexes of Primary?
Ensure brevity in your answer.  9.06e+05. What is the difference between the highest and the second highest Number of enrolments of both sexes of Secondary?
Give a very brief answer. 6.76e+04. What is the difference between the highest and the second highest Number of enrolments of both sexes in Secondary general?
Your response must be concise. 2.44e+05. What is the difference between the highest and the second highest Number of enrolments of both sexes in Secondary vocational?
Ensure brevity in your answer.  2.16e+05. What is the difference between the highest and the lowest Number of enrolments of both sexes of Primary?
Make the answer very short. 2.20e+06. What is the difference between the highest and the lowest Number of enrolments of both sexes of Secondary?
Offer a very short reply. 2.51e+06. What is the difference between the highest and the lowest Number of enrolments of both sexes in Secondary general?
Your response must be concise. 2.00e+06. What is the difference between the highest and the lowest Number of enrolments of both sexes of Secondary vocational?
Provide a succinct answer. 9.64e+05. 